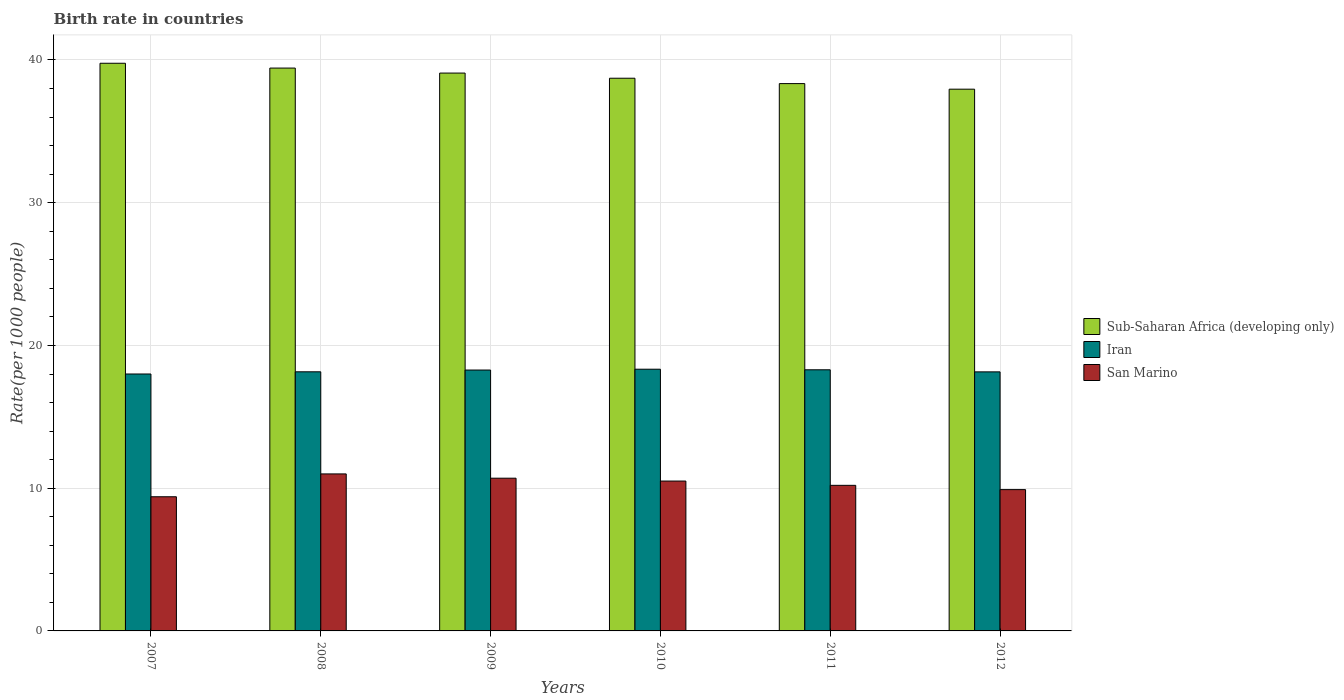How many different coloured bars are there?
Your response must be concise. 3. What is the label of the 2nd group of bars from the left?
Provide a succinct answer. 2008. In how many cases, is the number of bars for a given year not equal to the number of legend labels?
Your answer should be very brief. 0. What is the birth rate in Sub-Saharan Africa (developing only) in 2007?
Your answer should be very brief. 39.77. Across all years, what is the maximum birth rate in Sub-Saharan Africa (developing only)?
Provide a short and direct response. 39.77. Across all years, what is the minimum birth rate in Iran?
Keep it short and to the point. 18. In which year was the birth rate in San Marino maximum?
Keep it short and to the point. 2008. What is the total birth rate in Sub-Saharan Africa (developing only) in the graph?
Provide a succinct answer. 233.31. What is the difference between the birth rate in Iran in 2007 and that in 2011?
Keep it short and to the point. -0.29. What is the difference between the birth rate in San Marino in 2010 and the birth rate in Iran in 2009?
Ensure brevity in your answer.  -7.78. What is the average birth rate in Sub-Saharan Africa (developing only) per year?
Your response must be concise. 38.88. In the year 2012, what is the difference between the birth rate in San Marino and birth rate in Sub-Saharan Africa (developing only)?
Give a very brief answer. -28.05. In how many years, is the birth rate in San Marino greater than 26?
Make the answer very short. 0. What is the ratio of the birth rate in San Marino in 2009 to that in 2010?
Provide a succinct answer. 1.02. Is the difference between the birth rate in San Marino in 2009 and 2012 greater than the difference between the birth rate in Sub-Saharan Africa (developing only) in 2009 and 2012?
Your response must be concise. No. What is the difference between the highest and the second highest birth rate in Sub-Saharan Africa (developing only)?
Keep it short and to the point. 0.34. What is the difference between the highest and the lowest birth rate in Sub-Saharan Africa (developing only)?
Provide a succinct answer. 1.82. Is the sum of the birth rate in Iran in 2011 and 2012 greater than the maximum birth rate in San Marino across all years?
Make the answer very short. Yes. What does the 1st bar from the left in 2011 represents?
Give a very brief answer. Sub-Saharan Africa (developing only). What does the 1st bar from the right in 2011 represents?
Your response must be concise. San Marino. Is it the case that in every year, the sum of the birth rate in Sub-Saharan Africa (developing only) and birth rate in Iran is greater than the birth rate in San Marino?
Offer a very short reply. Yes. How many bars are there?
Provide a succinct answer. 18. How many legend labels are there?
Your answer should be very brief. 3. What is the title of the graph?
Make the answer very short. Birth rate in countries. What is the label or title of the X-axis?
Your answer should be compact. Years. What is the label or title of the Y-axis?
Keep it short and to the point. Rate(per 1000 people). What is the Rate(per 1000 people) of Sub-Saharan Africa (developing only) in 2007?
Offer a terse response. 39.77. What is the Rate(per 1000 people) in Iran in 2007?
Give a very brief answer. 18. What is the Rate(per 1000 people) in Sub-Saharan Africa (developing only) in 2008?
Your answer should be compact. 39.43. What is the Rate(per 1000 people) of Iran in 2008?
Ensure brevity in your answer.  18.15. What is the Rate(per 1000 people) in San Marino in 2008?
Your answer should be compact. 11. What is the Rate(per 1000 people) in Sub-Saharan Africa (developing only) in 2009?
Your answer should be compact. 39.08. What is the Rate(per 1000 people) in Iran in 2009?
Your answer should be very brief. 18.28. What is the Rate(per 1000 people) in San Marino in 2009?
Your response must be concise. 10.7. What is the Rate(per 1000 people) of Sub-Saharan Africa (developing only) in 2010?
Your answer should be very brief. 38.72. What is the Rate(per 1000 people) in Iran in 2010?
Offer a very short reply. 18.34. What is the Rate(per 1000 people) of Sub-Saharan Africa (developing only) in 2011?
Give a very brief answer. 38.35. What is the Rate(per 1000 people) of Iran in 2011?
Make the answer very short. 18.3. What is the Rate(per 1000 people) of San Marino in 2011?
Provide a short and direct response. 10.2. What is the Rate(per 1000 people) in Sub-Saharan Africa (developing only) in 2012?
Provide a succinct answer. 37.95. What is the Rate(per 1000 people) of Iran in 2012?
Offer a very short reply. 18.15. Across all years, what is the maximum Rate(per 1000 people) of Sub-Saharan Africa (developing only)?
Keep it short and to the point. 39.77. Across all years, what is the maximum Rate(per 1000 people) of Iran?
Make the answer very short. 18.34. Across all years, what is the maximum Rate(per 1000 people) of San Marino?
Make the answer very short. 11. Across all years, what is the minimum Rate(per 1000 people) in Sub-Saharan Africa (developing only)?
Your answer should be very brief. 37.95. Across all years, what is the minimum Rate(per 1000 people) of Iran?
Keep it short and to the point. 18. What is the total Rate(per 1000 people) of Sub-Saharan Africa (developing only) in the graph?
Your answer should be very brief. 233.31. What is the total Rate(per 1000 people) of Iran in the graph?
Give a very brief answer. 109.21. What is the total Rate(per 1000 people) of San Marino in the graph?
Provide a short and direct response. 61.7. What is the difference between the Rate(per 1000 people) in Sub-Saharan Africa (developing only) in 2007 and that in 2008?
Your answer should be very brief. 0.34. What is the difference between the Rate(per 1000 people) of Iran in 2007 and that in 2008?
Your answer should be compact. -0.15. What is the difference between the Rate(per 1000 people) in San Marino in 2007 and that in 2008?
Make the answer very short. -1.6. What is the difference between the Rate(per 1000 people) in Sub-Saharan Africa (developing only) in 2007 and that in 2009?
Offer a very short reply. 0.69. What is the difference between the Rate(per 1000 people) of Iran in 2007 and that in 2009?
Offer a very short reply. -0.28. What is the difference between the Rate(per 1000 people) of Sub-Saharan Africa (developing only) in 2007 and that in 2010?
Make the answer very short. 1.05. What is the difference between the Rate(per 1000 people) in Iran in 2007 and that in 2010?
Give a very brief answer. -0.34. What is the difference between the Rate(per 1000 people) in San Marino in 2007 and that in 2010?
Make the answer very short. -1.1. What is the difference between the Rate(per 1000 people) in Sub-Saharan Africa (developing only) in 2007 and that in 2011?
Your answer should be compact. 1.43. What is the difference between the Rate(per 1000 people) in Iran in 2007 and that in 2011?
Offer a terse response. -0.29. What is the difference between the Rate(per 1000 people) of San Marino in 2007 and that in 2011?
Your response must be concise. -0.8. What is the difference between the Rate(per 1000 people) in Sub-Saharan Africa (developing only) in 2007 and that in 2012?
Offer a terse response. 1.82. What is the difference between the Rate(per 1000 people) in Iran in 2007 and that in 2012?
Your answer should be very brief. -0.15. What is the difference between the Rate(per 1000 people) of San Marino in 2007 and that in 2012?
Your response must be concise. -0.5. What is the difference between the Rate(per 1000 people) in Sub-Saharan Africa (developing only) in 2008 and that in 2009?
Keep it short and to the point. 0.35. What is the difference between the Rate(per 1000 people) in Iran in 2008 and that in 2009?
Provide a short and direct response. -0.12. What is the difference between the Rate(per 1000 people) in San Marino in 2008 and that in 2009?
Give a very brief answer. 0.3. What is the difference between the Rate(per 1000 people) of Sub-Saharan Africa (developing only) in 2008 and that in 2010?
Your answer should be very brief. 0.71. What is the difference between the Rate(per 1000 people) in Iran in 2008 and that in 2010?
Offer a terse response. -0.18. What is the difference between the Rate(per 1000 people) of San Marino in 2008 and that in 2010?
Give a very brief answer. 0.5. What is the difference between the Rate(per 1000 people) in Sub-Saharan Africa (developing only) in 2008 and that in 2011?
Ensure brevity in your answer.  1.09. What is the difference between the Rate(per 1000 people) of Iran in 2008 and that in 2011?
Make the answer very short. -0.14. What is the difference between the Rate(per 1000 people) in San Marino in 2008 and that in 2011?
Your answer should be compact. 0.8. What is the difference between the Rate(per 1000 people) in Sub-Saharan Africa (developing only) in 2008 and that in 2012?
Your answer should be compact. 1.48. What is the difference between the Rate(per 1000 people) of Iran in 2008 and that in 2012?
Offer a very short reply. 0. What is the difference between the Rate(per 1000 people) of San Marino in 2008 and that in 2012?
Offer a very short reply. 1.1. What is the difference between the Rate(per 1000 people) in Sub-Saharan Africa (developing only) in 2009 and that in 2010?
Your answer should be very brief. 0.36. What is the difference between the Rate(per 1000 people) of Iran in 2009 and that in 2010?
Your answer should be compact. -0.06. What is the difference between the Rate(per 1000 people) of San Marino in 2009 and that in 2010?
Provide a short and direct response. 0.2. What is the difference between the Rate(per 1000 people) of Sub-Saharan Africa (developing only) in 2009 and that in 2011?
Provide a short and direct response. 0.74. What is the difference between the Rate(per 1000 people) in Iran in 2009 and that in 2011?
Give a very brief answer. -0.02. What is the difference between the Rate(per 1000 people) in San Marino in 2009 and that in 2011?
Keep it short and to the point. 0.5. What is the difference between the Rate(per 1000 people) of Sub-Saharan Africa (developing only) in 2009 and that in 2012?
Your answer should be very brief. 1.13. What is the difference between the Rate(per 1000 people) of Iran in 2009 and that in 2012?
Provide a succinct answer. 0.13. What is the difference between the Rate(per 1000 people) in Sub-Saharan Africa (developing only) in 2010 and that in 2011?
Make the answer very short. 0.38. What is the difference between the Rate(per 1000 people) in Iran in 2010 and that in 2011?
Your answer should be very brief. 0.04. What is the difference between the Rate(per 1000 people) of San Marino in 2010 and that in 2011?
Offer a very short reply. 0.3. What is the difference between the Rate(per 1000 people) in Sub-Saharan Africa (developing only) in 2010 and that in 2012?
Ensure brevity in your answer.  0.77. What is the difference between the Rate(per 1000 people) in Iran in 2010 and that in 2012?
Give a very brief answer. 0.19. What is the difference between the Rate(per 1000 people) in Sub-Saharan Africa (developing only) in 2011 and that in 2012?
Offer a terse response. 0.39. What is the difference between the Rate(per 1000 people) of Iran in 2011 and that in 2012?
Offer a very short reply. 0.14. What is the difference between the Rate(per 1000 people) in San Marino in 2011 and that in 2012?
Ensure brevity in your answer.  0.3. What is the difference between the Rate(per 1000 people) of Sub-Saharan Africa (developing only) in 2007 and the Rate(per 1000 people) of Iran in 2008?
Your answer should be very brief. 21.62. What is the difference between the Rate(per 1000 people) of Sub-Saharan Africa (developing only) in 2007 and the Rate(per 1000 people) of San Marino in 2008?
Offer a very short reply. 28.77. What is the difference between the Rate(per 1000 people) of Iran in 2007 and the Rate(per 1000 people) of San Marino in 2008?
Give a very brief answer. 7. What is the difference between the Rate(per 1000 people) in Sub-Saharan Africa (developing only) in 2007 and the Rate(per 1000 people) in Iran in 2009?
Your response must be concise. 21.49. What is the difference between the Rate(per 1000 people) of Sub-Saharan Africa (developing only) in 2007 and the Rate(per 1000 people) of San Marino in 2009?
Offer a terse response. 29.07. What is the difference between the Rate(per 1000 people) in Iran in 2007 and the Rate(per 1000 people) in San Marino in 2009?
Ensure brevity in your answer.  7.3. What is the difference between the Rate(per 1000 people) of Sub-Saharan Africa (developing only) in 2007 and the Rate(per 1000 people) of Iran in 2010?
Your answer should be compact. 21.43. What is the difference between the Rate(per 1000 people) in Sub-Saharan Africa (developing only) in 2007 and the Rate(per 1000 people) in San Marino in 2010?
Provide a succinct answer. 29.27. What is the difference between the Rate(per 1000 people) of Iran in 2007 and the Rate(per 1000 people) of San Marino in 2010?
Keep it short and to the point. 7.5. What is the difference between the Rate(per 1000 people) in Sub-Saharan Africa (developing only) in 2007 and the Rate(per 1000 people) in Iran in 2011?
Offer a terse response. 21.48. What is the difference between the Rate(per 1000 people) of Sub-Saharan Africa (developing only) in 2007 and the Rate(per 1000 people) of San Marino in 2011?
Your answer should be compact. 29.57. What is the difference between the Rate(per 1000 people) in Iran in 2007 and the Rate(per 1000 people) in San Marino in 2011?
Offer a terse response. 7.8. What is the difference between the Rate(per 1000 people) of Sub-Saharan Africa (developing only) in 2007 and the Rate(per 1000 people) of Iran in 2012?
Your answer should be very brief. 21.62. What is the difference between the Rate(per 1000 people) of Sub-Saharan Africa (developing only) in 2007 and the Rate(per 1000 people) of San Marino in 2012?
Your answer should be compact. 29.87. What is the difference between the Rate(per 1000 people) of Iran in 2007 and the Rate(per 1000 people) of San Marino in 2012?
Offer a terse response. 8.1. What is the difference between the Rate(per 1000 people) of Sub-Saharan Africa (developing only) in 2008 and the Rate(per 1000 people) of Iran in 2009?
Provide a succinct answer. 21.16. What is the difference between the Rate(per 1000 people) of Sub-Saharan Africa (developing only) in 2008 and the Rate(per 1000 people) of San Marino in 2009?
Your answer should be very brief. 28.73. What is the difference between the Rate(per 1000 people) in Iran in 2008 and the Rate(per 1000 people) in San Marino in 2009?
Ensure brevity in your answer.  7.45. What is the difference between the Rate(per 1000 people) in Sub-Saharan Africa (developing only) in 2008 and the Rate(per 1000 people) in Iran in 2010?
Provide a short and direct response. 21.1. What is the difference between the Rate(per 1000 people) in Sub-Saharan Africa (developing only) in 2008 and the Rate(per 1000 people) in San Marino in 2010?
Your answer should be compact. 28.93. What is the difference between the Rate(per 1000 people) of Iran in 2008 and the Rate(per 1000 people) of San Marino in 2010?
Provide a short and direct response. 7.65. What is the difference between the Rate(per 1000 people) of Sub-Saharan Africa (developing only) in 2008 and the Rate(per 1000 people) of Iran in 2011?
Give a very brief answer. 21.14. What is the difference between the Rate(per 1000 people) in Sub-Saharan Africa (developing only) in 2008 and the Rate(per 1000 people) in San Marino in 2011?
Your response must be concise. 29.23. What is the difference between the Rate(per 1000 people) in Iran in 2008 and the Rate(per 1000 people) in San Marino in 2011?
Your answer should be compact. 7.95. What is the difference between the Rate(per 1000 people) of Sub-Saharan Africa (developing only) in 2008 and the Rate(per 1000 people) of Iran in 2012?
Your response must be concise. 21.28. What is the difference between the Rate(per 1000 people) in Sub-Saharan Africa (developing only) in 2008 and the Rate(per 1000 people) in San Marino in 2012?
Offer a very short reply. 29.53. What is the difference between the Rate(per 1000 people) in Iran in 2008 and the Rate(per 1000 people) in San Marino in 2012?
Your answer should be very brief. 8.25. What is the difference between the Rate(per 1000 people) of Sub-Saharan Africa (developing only) in 2009 and the Rate(per 1000 people) of Iran in 2010?
Provide a short and direct response. 20.75. What is the difference between the Rate(per 1000 people) in Sub-Saharan Africa (developing only) in 2009 and the Rate(per 1000 people) in San Marino in 2010?
Ensure brevity in your answer.  28.58. What is the difference between the Rate(per 1000 people) in Iran in 2009 and the Rate(per 1000 people) in San Marino in 2010?
Provide a succinct answer. 7.78. What is the difference between the Rate(per 1000 people) of Sub-Saharan Africa (developing only) in 2009 and the Rate(per 1000 people) of Iran in 2011?
Your answer should be very brief. 20.79. What is the difference between the Rate(per 1000 people) of Sub-Saharan Africa (developing only) in 2009 and the Rate(per 1000 people) of San Marino in 2011?
Keep it short and to the point. 28.88. What is the difference between the Rate(per 1000 people) of Iran in 2009 and the Rate(per 1000 people) of San Marino in 2011?
Give a very brief answer. 8.08. What is the difference between the Rate(per 1000 people) of Sub-Saharan Africa (developing only) in 2009 and the Rate(per 1000 people) of Iran in 2012?
Make the answer very short. 20.93. What is the difference between the Rate(per 1000 people) of Sub-Saharan Africa (developing only) in 2009 and the Rate(per 1000 people) of San Marino in 2012?
Your response must be concise. 29.18. What is the difference between the Rate(per 1000 people) in Iran in 2009 and the Rate(per 1000 people) in San Marino in 2012?
Provide a succinct answer. 8.38. What is the difference between the Rate(per 1000 people) of Sub-Saharan Africa (developing only) in 2010 and the Rate(per 1000 people) of Iran in 2011?
Keep it short and to the point. 20.43. What is the difference between the Rate(per 1000 people) of Sub-Saharan Africa (developing only) in 2010 and the Rate(per 1000 people) of San Marino in 2011?
Your response must be concise. 28.52. What is the difference between the Rate(per 1000 people) of Iran in 2010 and the Rate(per 1000 people) of San Marino in 2011?
Your answer should be compact. 8.14. What is the difference between the Rate(per 1000 people) of Sub-Saharan Africa (developing only) in 2010 and the Rate(per 1000 people) of Iran in 2012?
Keep it short and to the point. 20.57. What is the difference between the Rate(per 1000 people) of Sub-Saharan Africa (developing only) in 2010 and the Rate(per 1000 people) of San Marino in 2012?
Make the answer very short. 28.82. What is the difference between the Rate(per 1000 people) in Iran in 2010 and the Rate(per 1000 people) in San Marino in 2012?
Give a very brief answer. 8.44. What is the difference between the Rate(per 1000 people) of Sub-Saharan Africa (developing only) in 2011 and the Rate(per 1000 people) of Iran in 2012?
Your answer should be compact. 20.2. What is the difference between the Rate(per 1000 people) of Sub-Saharan Africa (developing only) in 2011 and the Rate(per 1000 people) of San Marino in 2012?
Your answer should be compact. 28.45. What is the difference between the Rate(per 1000 people) in Iran in 2011 and the Rate(per 1000 people) in San Marino in 2012?
Ensure brevity in your answer.  8.39. What is the average Rate(per 1000 people) in Sub-Saharan Africa (developing only) per year?
Provide a short and direct response. 38.88. What is the average Rate(per 1000 people) of Iran per year?
Make the answer very short. 18.2. What is the average Rate(per 1000 people) of San Marino per year?
Provide a succinct answer. 10.28. In the year 2007, what is the difference between the Rate(per 1000 people) in Sub-Saharan Africa (developing only) and Rate(per 1000 people) in Iran?
Keep it short and to the point. 21.77. In the year 2007, what is the difference between the Rate(per 1000 people) of Sub-Saharan Africa (developing only) and Rate(per 1000 people) of San Marino?
Ensure brevity in your answer.  30.37. In the year 2007, what is the difference between the Rate(per 1000 people) in Iran and Rate(per 1000 people) in San Marino?
Provide a short and direct response. 8.6. In the year 2008, what is the difference between the Rate(per 1000 people) in Sub-Saharan Africa (developing only) and Rate(per 1000 people) in Iran?
Your answer should be compact. 21.28. In the year 2008, what is the difference between the Rate(per 1000 people) in Sub-Saharan Africa (developing only) and Rate(per 1000 people) in San Marino?
Offer a very short reply. 28.43. In the year 2008, what is the difference between the Rate(per 1000 people) in Iran and Rate(per 1000 people) in San Marino?
Offer a terse response. 7.15. In the year 2009, what is the difference between the Rate(per 1000 people) in Sub-Saharan Africa (developing only) and Rate(per 1000 people) in Iran?
Give a very brief answer. 20.81. In the year 2009, what is the difference between the Rate(per 1000 people) in Sub-Saharan Africa (developing only) and Rate(per 1000 people) in San Marino?
Offer a terse response. 28.38. In the year 2009, what is the difference between the Rate(per 1000 people) in Iran and Rate(per 1000 people) in San Marino?
Your answer should be compact. 7.58. In the year 2010, what is the difference between the Rate(per 1000 people) of Sub-Saharan Africa (developing only) and Rate(per 1000 people) of Iran?
Provide a short and direct response. 20.39. In the year 2010, what is the difference between the Rate(per 1000 people) of Sub-Saharan Africa (developing only) and Rate(per 1000 people) of San Marino?
Ensure brevity in your answer.  28.22. In the year 2010, what is the difference between the Rate(per 1000 people) in Iran and Rate(per 1000 people) in San Marino?
Give a very brief answer. 7.84. In the year 2011, what is the difference between the Rate(per 1000 people) of Sub-Saharan Africa (developing only) and Rate(per 1000 people) of Iran?
Your answer should be very brief. 20.05. In the year 2011, what is the difference between the Rate(per 1000 people) in Sub-Saharan Africa (developing only) and Rate(per 1000 people) in San Marino?
Offer a terse response. 28.15. In the year 2011, what is the difference between the Rate(per 1000 people) of Iran and Rate(per 1000 people) of San Marino?
Your response must be concise. 8.1. In the year 2012, what is the difference between the Rate(per 1000 people) in Sub-Saharan Africa (developing only) and Rate(per 1000 people) in Iran?
Your response must be concise. 19.8. In the year 2012, what is the difference between the Rate(per 1000 people) of Sub-Saharan Africa (developing only) and Rate(per 1000 people) of San Marino?
Keep it short and to the point. 28.05. In the year 2012, what is the difference between the Rate(per 1000 people) of Iran and Rate(per 1000 people) of San Marino?
Keep it short and to the point. 8.25. What is the ratio of the Rate(per 1000 people) of Sub-Saharan Africa (developing only) in 2007 to that in 2008?
Your answer should be very brief. 1.01. What is the ratio of the Rate(per 1000 people) in San Marino in 2007 to that in 2008?
Your answer should be very brief. 0.85. What is the ratio of the Rate(per 1000 people) in Sub-Saharan Africa (developing only) in 2007 to that in 2009?
Keep it short and to the point. 1.02. What is the ratio of the Rate(per 1000 people) of Iran in 2007 to that in 2009?
Keep it short and to the point. 0.98. What is the ratio of the Rate(per 1000 people) of San Marino in 2007 to that in 2009?
Your answer should be compact. 0.88. What is the ratio of the Rate(per 1000 people) of Sub-Saharan Africa (developing only) in 2007 to that in 2010?
Offer a terse response. 1.03. What is the ratio of the Rate(per 1000 people) in Iran in 2007 to that in 2010?
Keep it short and to the point. 0.98. What is the ratio of the Rate(per 1000 people) in San Marino in 2007 to that in 2010?
Make the answer very short. 0.9. What is the ratio of the Rate(per 1000 people) in Sub-Saharan Africa (developing only) in 2007 to that in 2011?
Your answer should be very brief. 1.04. What is the ratio of the Rate(per 1000 people) of Iran in 2007 to that in 2011?
Provide a succinct answer. 0.98. What is the ratio of the Rate(per 1000 people) of San Marino in 2007 to that in 2011?
Keep it short and to the point. 0.92. What is the ratio of the Rate(per 1000 people) in Sub-Saharan Africa (developing only) in 2007 to that in 2012?
Ensure brevity in your answer.  1.05. What is the ratio of the Rate(per 1000 people) in Iran in 2007 to that in 2012?
Your response must be concise. 0.99. What is the ratio of the Rate(per 1000 people) of San Marino in 2007 to that in 2012?
Offer a terse response. 0.95. What is the ratio of the Rate(per 1000 people) of Sub-Saharan Africa (developing only) in 2008 to that in 2009?
Ensure brevity in your answer.  1.01. What is the ratio of the Rate(per 1000 people) in San Marino in 2008 to that in 2009?
Offer a very short reply. 1.03. What is the ratio of the Rate(per 1000 people) in Sub-Saharan Africa (developing only) in 2008 to that in 2010?
Your answer should be very brief. 1.02. What is the ratio of the Rate(per 1000 people) of San Marino in 2008 to that in 2010?
Offer a terse response. 1.05. What is the ratio of the Rate(per 1000 people) of Sub-Saharan Africa (developing only) in 2008 to that in 2011?
Offer a terse response. 1.03. What is the ratio of the Rate(per 1000 people) in San Marino in 2008 to that in 2011?
Give a very brief answer. 1.08. What is the ratio of the Rate(per 1000 people) in Sub-Saharan Africa (developing only) in 2008 to that in 2012?
Your answer should be compact. 1.04. What is the ratio of the Rate(per 1000 people) in San Marino in 2008 to that in 2012?
Provide a short and direct response. 1.11. What is the ratio of the Rate(per 1000 people) in Sub-Saharan Africa (developing only) in 2009 to that in 2010?
Give a very brief answer. 1.01. What is the ratio of the Rate(per 1000 people) of Iran in 2009 to that in 2010?
Offer a very short reply. 1. What is the ratio of the Rate(per 1000 people) of Sub-Saharan Africa (developing only) in 2009 to that in 2011?
Ensure brevity in your answer.  1.02. What is the ratio of the Rate(per 1000 people) of San Marino in 2009 to that in 2011?
Offer a terse response. 1.05. What is the ratio of the Rate(per 1000 people) in Sub-Saharan Africa (developing only) in 2009 to that in 2012?
Offer a very short reply. 1.03. What is the ratio of the Rate(per 1000 people) of Iran in 2009 to that in 2012?
Your response must be concise. 1.01. What is the ratio of the Rate(per 1000 people) in San Marino in 2009 to that in 2012?
Ensure brevity in your answer.  1.08. What is the ratio of the Rate(per 1000 people) of Sub-Saharan Africa (developing only) in 2010 to that in 2011?
Your response must be concise. 1.01. What is the ratio of the Rate(per 1000 people) of San Marino in 2010 to that in 2011?
Your answer should be compact. 1.03. What is the ratio of the Rate(per 1000 people) in Sub-Saharan Africa (developing only) in 2010 to that in 2012?
Your answer should be very brief. 1.02. What is the ratio of the Rate(per 1000 people) in Iran in 2010 to that in 2012?
Provide a succinct answer. 1.01. What is the ratio of the Rate(per 1000 people) in San Marino in 2010 to that in 2012?
Offer a terse response. 1.06. What is the ratio of the Rate(per 1000 people) in Sub-Saharan Africa (developing only) in 2011 to that in 2012?
Provide a succinct answer. 1.01. What is the ratio of the Rate(per 1000 people) of San Marino in 2011 to that in 2012?
Keep it short and to the point. 1.03. What is the difference between the highest and the second highest Rate(per 1000 people) of Sub-Saharan Africa (developing only)?
Give a very brief answer. 0.34. What is the difference between the highest and the second highest Rate(per 1000 people) of Iran?
Provide a succinct answer. 0.04. What is the difference between the highest and the lowest Rate(per 1000 people) in Sub-Saharan Africa (developing only)?
Your answer should be compact. 1.82. What is the difference between the highest and the lowest Rate(per 1000 people) of Iran?
Provide a short and direct response. 0.34. 